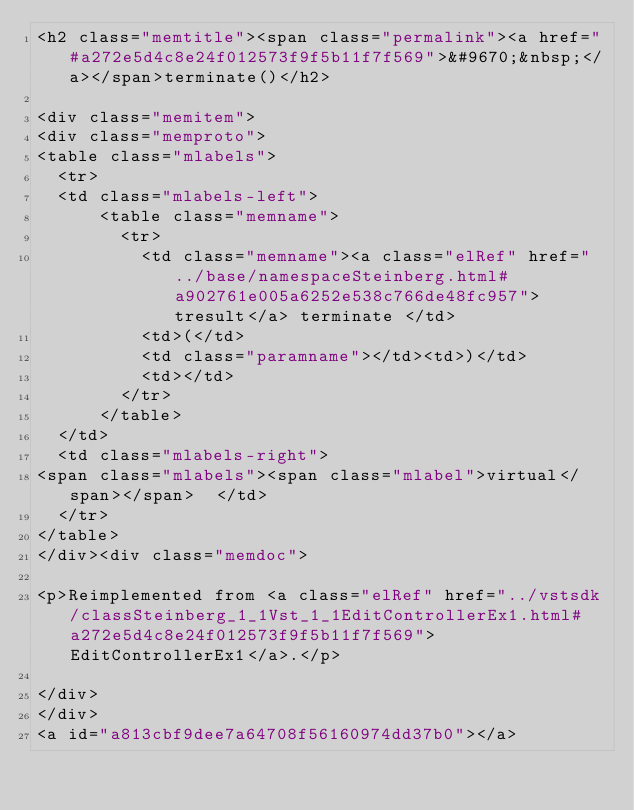Convert code to text. <code><loc_0><loc_0><loc_500><loc_500><_HTML_><h2 class="memtitle"><span class="permalink"><a href="#a272e5d4c8e24f012573f9f5b11f7f569">&#9670;&nbsp;</a></span>terminate()</h2>

<div class="memitem">
<div class="memproto">
<table class="mlabels">
  <tr>
  <td class="mlabels-left">
      <table class="memname">
        <tr>
          <td class="memname"><a class="elRef" href="../base/namespaceSteinberg.html#a902761e005a6252e538c766de48fc957">tresult</a> terminate </td>
          <td>(</td>
          <td class="paramname"></td><td>)</td>
          <td></td>
        </tr>
      </table>
  </td>
  <td class="mlabels-right">
<span class="mlabels"><span class="mlabel">virtual</span></span>  </td>
  </tr>
</table>
</div><div class="memdoc">

<p>Reimplemented from <a class="elRef" href="../vstsdk/classSteinberg_1_1Vst_1_1EditControllerEx1.html#a272e5d4c8e24f012573f9f5b11f7f569">EditControllerEx1</a>.</p>

</div>
</div>
<a id="a813cbf9dee7a64708f56160974dd37b0"></a></code> 